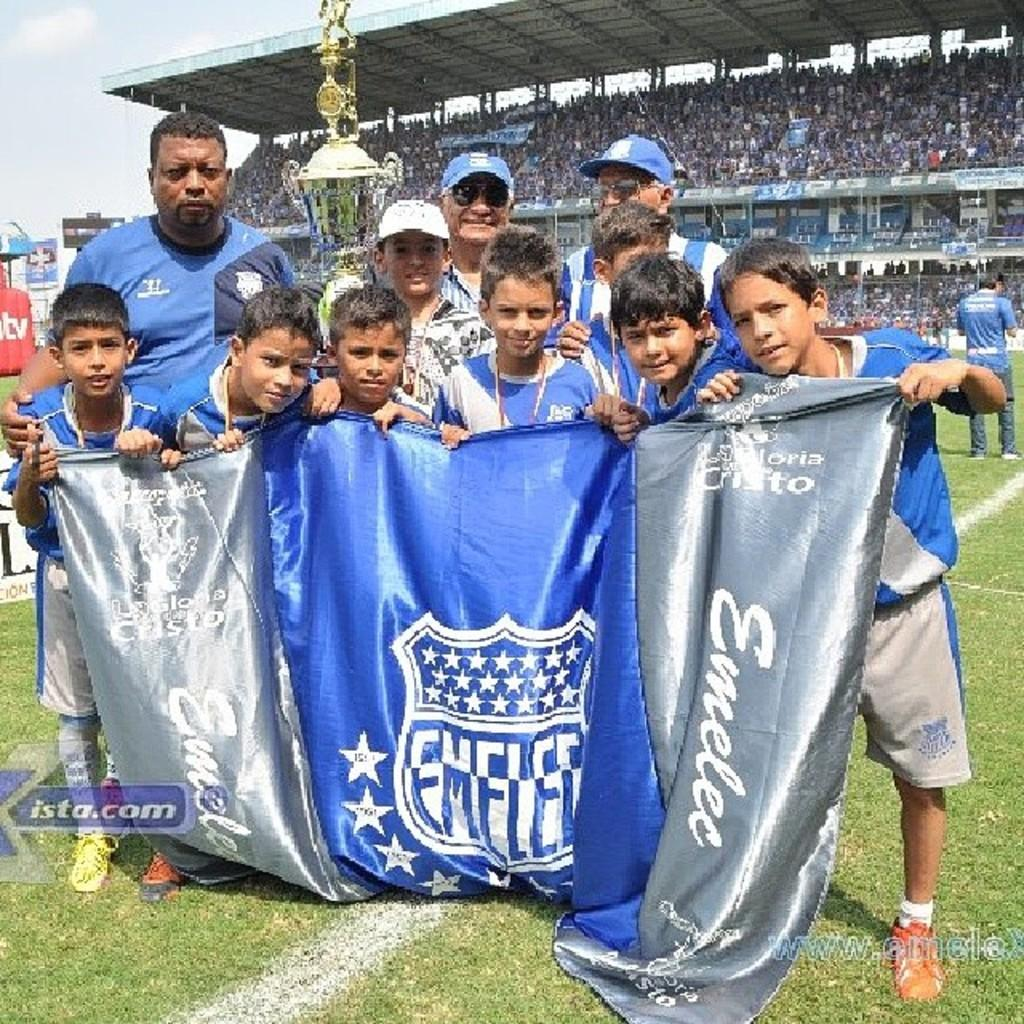Provide a one-sentence caption for the provided image. a small group of a boy's sports team holding a blue and silver banner that says Emelec on the field with fans in the stands behind them. 